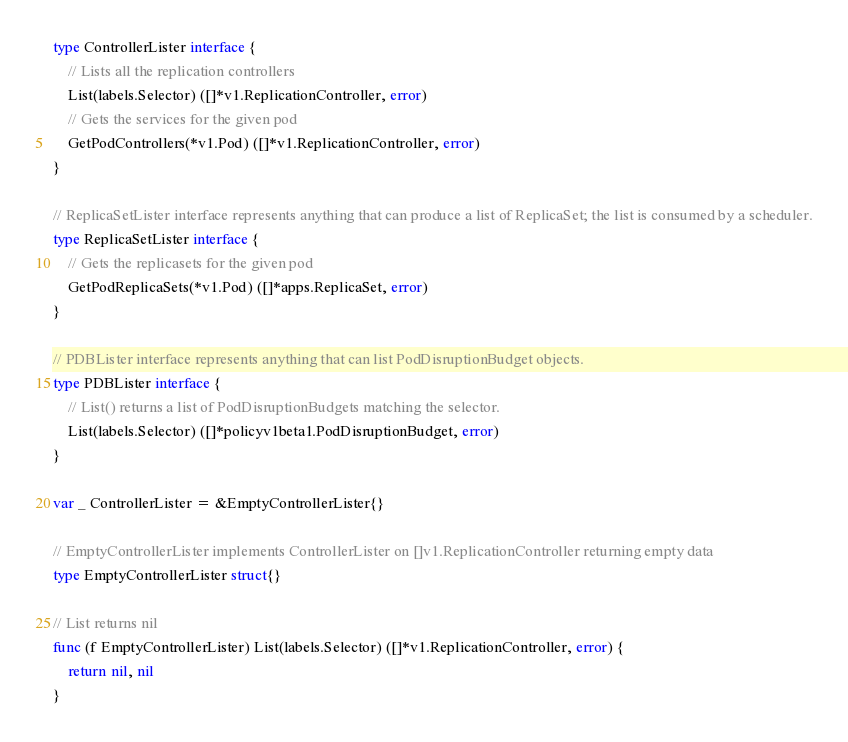Convert code to text. <code><loc_0><loc_0><loc_500><loc_500><_Go_>type ControllerLister interface {
	// Lists all the replication controllers
	List(labels.Selector) ([]*v1.ReplicationController, error)
	// Gets the services for the given pod
	GetPodControllers(*v1.Pod) ([]*v1.ReplicationController, error)
}

// ReplicaSetLister interface represents anything that can produce a list of ReplicaSet; the list is consumed by a scheduler.
type ReplicaSetLister interface {
	// Gets the replicasets for the given pod
	GetPodReplicaSets(*v1.Pod) ([]*apps.ReplicaSet, error)
}

// PDBLister interface represents anything that can list PodDisruptionBudget objects.
type PDBLister interface {
	// List() returns a list of PodDisruptionBudgets matching the selector.
	List(labels.Selector) ([]*policyv1beta1.PodDisruptionBudget, error)
}

var _ ControllerLister = &EmptyControllerLister{}

// EmptyControllerLister implements ControllerLister on []v1.ReplicationController returning empty data
type EmptyControllerLister struct{}

// List returns nil
func (f EmptyControllerLister) List(labels.Selector) ([]*v1.ReplicationController, error) {
	return nil, nil
}
</code> 